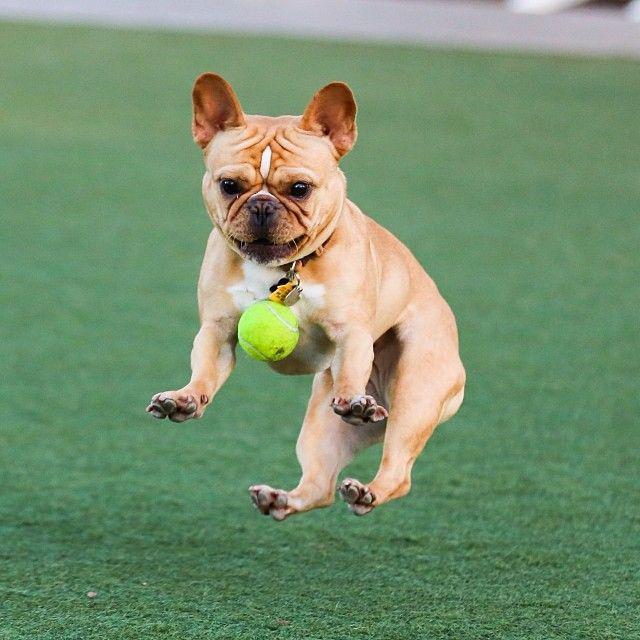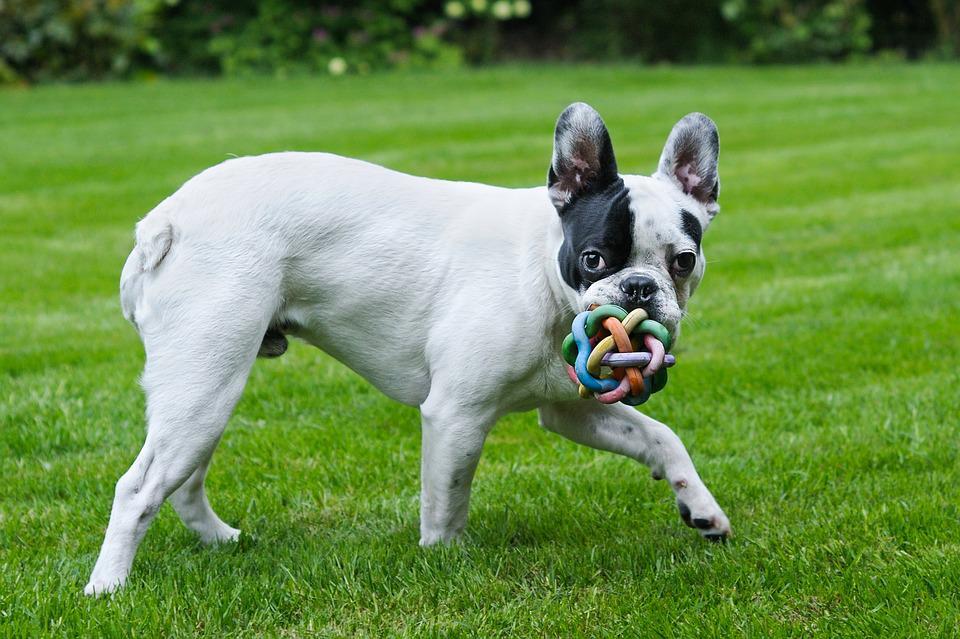The first image is the image on the left, the second image is the image on the right. Considering the images on both sides, is "An image shows a brown dog playing with a yellow tennis ball in an area with green ground." valid? Answer yes or no. Yes. The first image is the image on the left, the second image is the image on the right. For the images displayed, is the sentence "The dog in the image on the right is playing with a yellow ball." factually correct? Answer yes or no. No. 